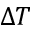<formula> <loc_0><loc_0><loc_500><loc_500>\Delta T</formula> 